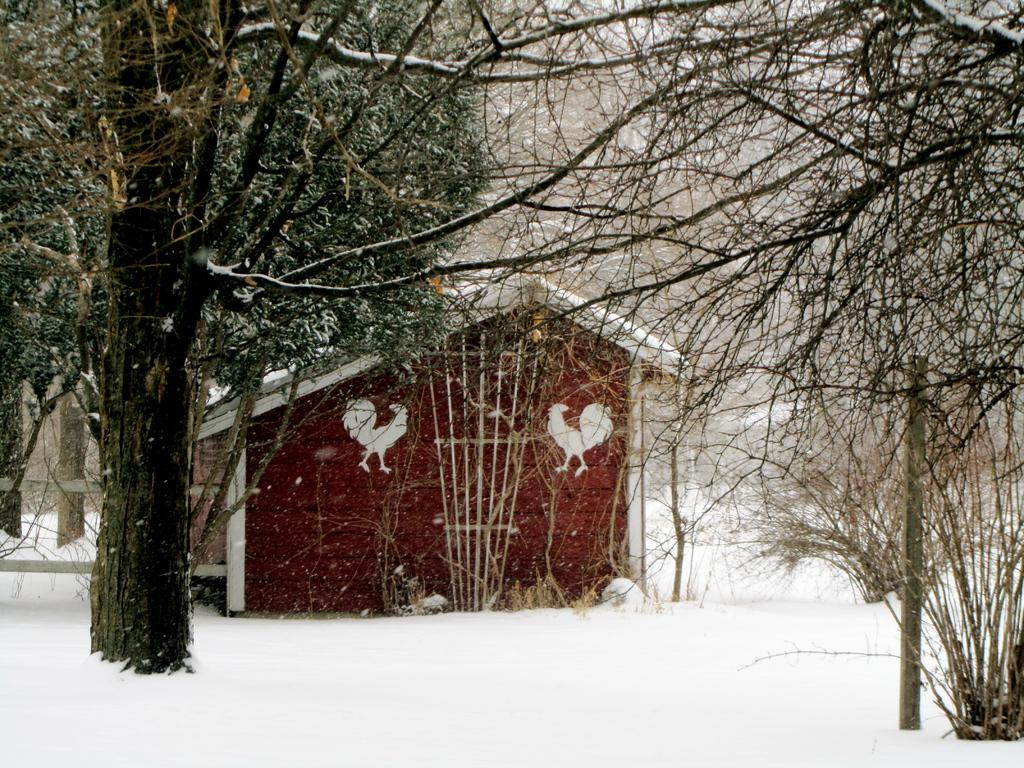What is the condition of the ground in the image? The ground is covered with snow in the image. What type of structure can be seen in the image? There is a house in the image. What type of vegetation is present in the image? There are trees in the image. What type of toys can be seen being crushed in the image? There are no toys present in the image, and therefore no such activity can be observed. 